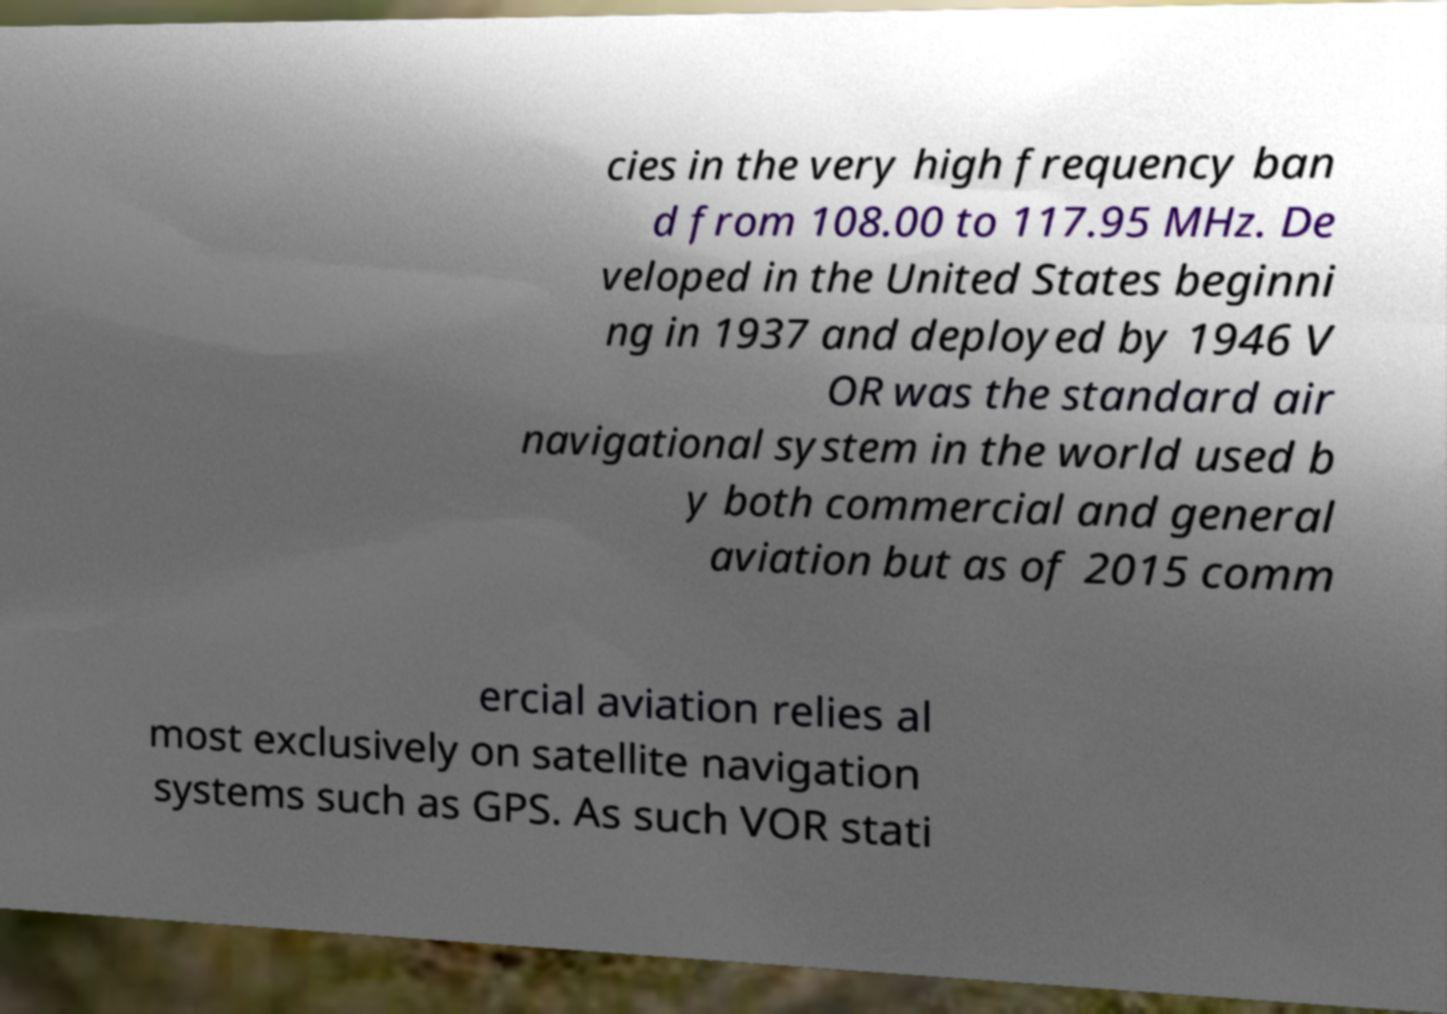Can you read and provide the text displayed in the image?This photo seems to have some interesting text. Can you extract and type it out for me? cies in the very high frequency ban d from 108.00 to 117.95 MHz. De veloped in the United States beginni ng in 1937 and deployed by 1946 V OR was the standard air navigational system in the world used b y both commercial and general aviation but as of 2015 comm ercial aviation relies al most exclusively on satellite navigation systems such as GPS. As such VOR stati 